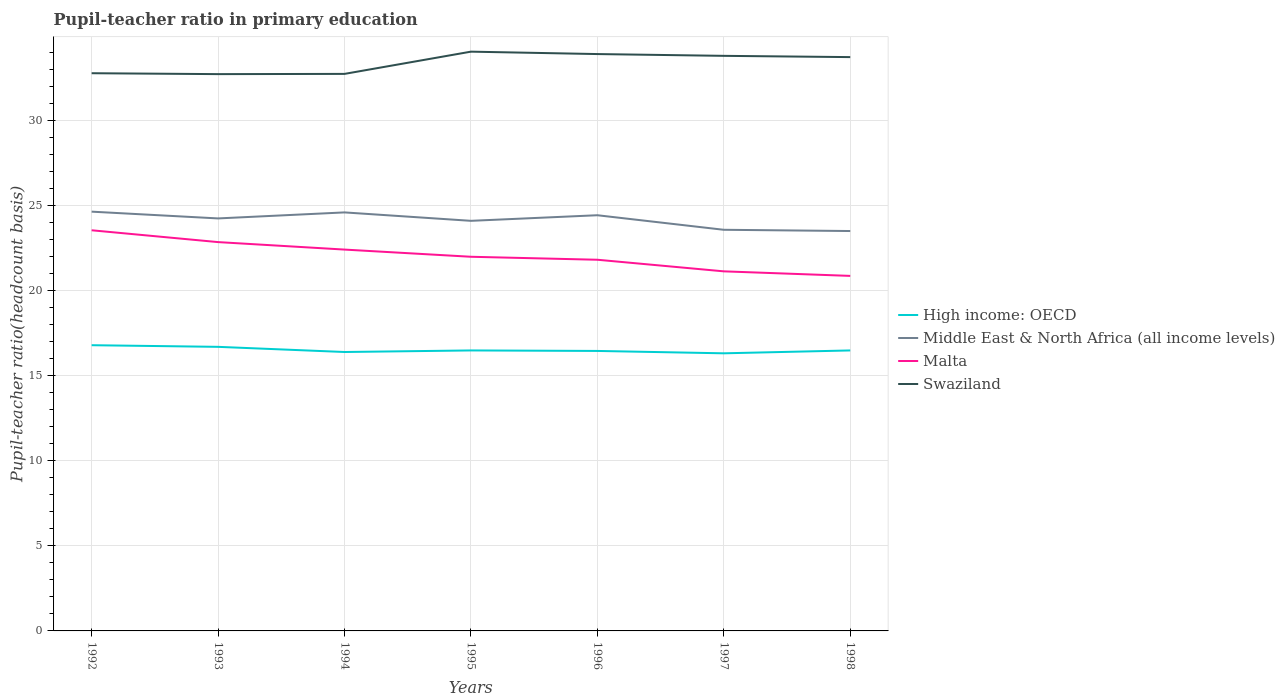How many different coloured lines are there?
Ensure brevity in your answer.  4. Is the number of lines equal to the number of legend labels?
Provide a short and direct response. Yes. Across all years, what is the maximum pupil-teacher ratio in primary education in High income: OECD?
Make the answer very short. 16.3. What is the total pupil-teacher ratio in primary education in Middle East & North Africa (all income levels) in the graph?
Give a very brief answer. 0.07. What is the difference between the highest and the second highest pupil-teacher ratio in primary education in Swaziland?
Offer a very short reply. 1.32. How many lines are there?
Your answer should be compact. 4. How many years are there in the graph?
Provide a short and direct response. 7. Are the values on the major ticks of Y-axis written in scientific E-notation?
Make the answer very short. No. Does the graph contain any zero values?
Offer a terse response. No. Does the graph contain grids?
Ensure brevity in your answer.  Yes. How many legend labels are there?
Give a very brief answer. 4. What is the title of the graph?
Your response must be concise. Pupil-teacher ratio in primary education. What is the label or title of the Y-axis?
Provide a succinct answer. Pupil-teacher ratio(headcount basis). What is the Pupil-teacher ratio(headcount basis) in High income: OECD in 1992?
Keep it short and to the point. 16.78. What is the Pupil-teacher ratio(headcount basis) in Middle East & North Africa (all income levels) in 1992?
Offer a terse response. 24.62. What is the Pupil-teacher ratio(headcount basis) in Malta in 1992?
Provide a short and direct response. 23.53. What is the Pupil-teacher ratio(headcount basis) of Swaziland in 1992?
Your answer should be very brief. 32.76. What is the Pupil-teacher ratio(headcount basis) in High income: OECD in 1993?
Provide a succinct answer. 16.68. What is the Pupil-teacher ratio(headcount basis) in Middle East & North Africa (all income levels) in 1993?
Your answer should be very brief. 24.23. What is the Pupil-teacher ratio(headcount basis) in Malta in 1993?
Offer a terse response. 22.84. What is the Pupil-teacher ratio(headcount basis) of Swaziland in 1993?
Your answer should be very brief. 32.7. What is the Pupil-teacher ratio(headcount basis) of High income: OECD in 1994?
Make the answer very short. 16.38. What is the Pupil-teacher ratio(headcount basis) of Middle East & North Africa (all income levels) in 1994?
Ensure brevity in your answer.  24.58. What is the Pupil-teacher ratio(headcount basis) in Malta in 1994?
Keep it short and to the point. 22.4. What is the Pupil-teacher ratio(headcount basis) of Swaziland in 1994?
Ensure brevity in your answer.  32.72. What is the Pupil-teacher ratio(headcount basis) in High income: OECD in 1995?
Your response must be concise. 16.47. What is the Pupil-teacher ratio(headcount basis) in Middle East & North Africa (all income levels) in 1995?
Ensure brevity in your answer.  24.09. What is the Pupil-teacher ratio(headcount basis) of Malta in 1995?
Make the answer very short. 21.98. What is the Pupil-teacher ratio(headcount basis) in Swaziland in 1995?
Offer a very short reply. 34.02. What is the Pupil-teacher ratio(headcount basis) of High income: OECD in 1996?
Provide a short and direct response. 16.44. What is the Pupil-teacher ratio(headcount basis) in Middle East & North Africa (all income levels) in 1996?
Give a very brief answer. 24.41. What is the Pupil-teacher ratio(headcount basis) of Malta in 1996?
Make the answer very short. 21.8. What is the Pupil-teacher ratio(headcount basis) of Swaziland in 1996?
Provide a short and direct response. 33.88. What is the Pupil-teacher ratio(headcount basis) of High income: OECD in 1997?
Ensure brevity in your answer.  16.3. What is the Pupil-teacher ratio(headcount basis) in Middle East & North Africa (all income levels) in 1997?
Provide a short and direct response. 23.56. What is the Pupil-teacher ratio(headcount basis) in Malta in 1997?
Give a very brief answer. 21.12. What is the Pupil-teacher ratio(headcount basis) of Swaziland in 1997?
Make the answer very short. 33.78. What is the Pupil-teacher ratio(headcount basis) in High income: OECD in 1998?
Offer a very short reply. 16.47. What is the Pupil-teacher ratio(headcount basis) of Middle East & North Africa (all income levels) in 1998?
Provide a succinct answer. 23.49. What is the Pupil-teacher ratio(headcount basis) of Malta in 1998?
Your answer should be very brief. 20.85. What is the Pupil-teacher ratio(headcount basis) of Swaziland in 1998?
Give a very brief answer. 33.7. Across all years, what is the maximum Pupil-teacher ratio(headcount basis) of High income: OECD?
Keep it short and to the point. 16.78. Across all years, what is the maximum Pupil-teacher ratio(headcount basis) in Middle East & North Africa (all income levels)?
Provide a short and direct response. 24.62. Across all years, what is the maximum Pupil-teacher ratio(headcount basis) in Malta?
Give a very brief answer. 23.53. Across all years, what is the maximum Pupil-teacher ratio(headcount basis) in Swaziland?
Provide a short and direct response. 34.02. Across all years, what is the minimum Pupil-teacher ratio(headcount basis) of High income: OECD?
Offer a very short reply. 16.3. Across all years, what is the minimum Pupil-teacher ratio(headcount basis) in Middle East & North Africa (all income levels)?
Offer a terse response. 23.49. Across all years, what is the minimum Pupil-teacher ratio(headcount basis) in Malta?
Provide a short and direct response. 20.85. Across all years, what is the minimum Pupil-teacher ratio(headcount basis) in Swaziland?
Your response must be concise. 32.7. What is the total Pupil-teacher ratio(headcount basis) of High income: OECD in the graph?
Offer a very short reply. 115.54. What is the total Pupil-teacher ratio(headcount basis) of Middle East & North Africa (all income levels) in the graph?
Make the answer very short. 168.98. What is the total Pupil-teacher ratio(headcount basis) in Malta in the graph?
Your response must be concise. 154.51. What is the total Pupil-teacher ratio(headcount basis) in Swaziland in the graph?
Offer a very short reply. 233.55. What is the difference between the Pupil-teacher ratio(headcount basis) of High income: OECD in 1992 and that in 1993?
Provide a succinct answer. 0.1. What is the difference between the Pupil-teacher ratio(headcount basis) of Middle East & North Africa (all income levels) in 1992 and that in 1993?
Provide a short and direct response. 0.4. What is the difference between the Pupil-teacher ratio(headcount basis) in Malta in 1992 and that in 1993?
Offer a very short reply. 0.69. What is the difference between the Pupil-teacher ratio(headcount basis) in Swaziland in 1992 and that in 1993?
Ensure brevity in your answer.  0.05. What is the difference between the Pupil-teacher ratio(headcount basis) of High income: OECD in 1992 and that in 1994?
Your answer should be very brief. 0.4. What is the difference between the Pupil-teacher ratio(headcount basis) of Middle East & North Africa (all income levels) in 1992 and that in 1994?
Make the answer very short. 0.04. What is the difference between the Pupil-teacher ratio(headcount basis) in Malta in 1992 and that in 1994?
Your response must be concise. 1.13. What is the difference between the Pupil-teacher ratio(headcount basis) of Swaziland in 1992 and that in 1994?
Make the answer very short. 0.04. What is the difference between the Pupil-teacher ratio(headcount basis) of High income: OECD in 1992 and that in 1995?
Keep it short and to the point. 0.31. What is the difference between the Pupil-teacher ratio(headcount basis) in Middle East & North Africa (all income levels) in 1992 and that in 1995?
Offer a terse response. 0.54. What is the difference between the Pupil-teacher ratio(headcount basis) in Malta in 1992 and that in 1995?
Your response must be concise. 1.56. What is the difference between the Pupil-teacher ratio(headcount basis) of Swaziland in 1992 and that in 1995?
Your response must be concise. -1.27. What is the difference between the Pupil-teacher ratio(headcount basis) in High income: OECD in 1992 and that in 1996?
Your response must be concise. 0.34. What is the difference between the Pupil-teacher ratio(headcount basis) of Middle East & North Africa (all income levels) in 1992 and that in 1996?
Your answer should be very brief. 0.21. What is the difference between the Pupil-teacher ratio(headcount basis) in Malta in 1992 and that in 1996?
Your answer should be very brief. 1.73. What is the difference between the Pupil-teacher ratio(headcount basis) in Swaziland in 1992 and that in 1996?
Your answer should be compact. -1.13. What is the difference between the Pupil-teacher ratio(headcount basis) in High income: OECD in 1992 and that in 1997?
Your response must be concise. 0.48. What is the difference between the Pupil-teacher ratio(headcount basis) in Middle East & North Africa (all income levels) in 1992 and that in 1997?
Keep it short and to the point. 1.06. What is the difference between the Pupil-teacher ratio(headcount basis) of Malta in 1992 and that in 1997?
Offer a very short reply. 2.41. What is the difference between the Pupil-teacher ratio(headcount basis) of Swaziland in 1992 and that in 1997?
Your response must be concise. -1.02. What is the difference between the Pupil-teacher ratio(headcount basis) of High income: OECD in 1992 and that in 1998?
Your answer should be compact. 0.31. What is the difference between the Pupil-teacher ratio(headcount basis) in Middle East & North Africa (all income levels) in 1992 and that in 1998?
Keep it short and to the point. 1.14. What is the difference between the Pupil-teacher ratio(headcount basis) in Malta in 1992 and that in 1998?
Keep it short and to the point. 2.68. What is the difference between the Pupil-teacher ratio(headcount basis) in Swaziland in 1992 and that in 1998?
Offer a terse response. -0.95. What is the difference between the Pupil-teacher ratio(headcount basis) of High income: OECD in 1993 and that in 1994?
Your response must be concise. 0.3. What is the difference between the Pupil-teacher ratio(headcount basis) of Middle East & North Africa (all income levels) in 1993 and that in 1994?
Your response must be concise. -0.35. What is the difference between the Pupil-teacher ratio(headcount basis) of Malta in 1993 and that in 1994?
Ensure brevity in your answer.  0.44. What is the difference between the Pupil-teacher ratio(headcount basis) in Swaziland in 1993 and that in 1994?
Give a very brief answer. -0.01. What is the difference between the Pupil-teacher ratio(headcount basis) of High income: OECD in 1993 and that in 1995?
Your answer should be compact. 0.21. What is the difference between the Pupil-teacher ratio(headcount basis) in Middle East & North Africa (all income levels) in 1993 and that in 1995?
Your response must be concise. 0.14. What is the difference between the Pupil-teacher ratio(headcount basis) of Malta in 1993 and that in 1995?
Give a very brief answer. 0.86. What is the difference between the Pupil-teacher ratio(headcount basis) of Swaziland in 1993 and that in 1995?
Provide a short and direct response. -1.32. What is the difference between the Pupil-teacher ratio(headcount basis) of High income: OECD in 1993 and that in 1996?
Your answer should be very brief. 0.24. What is the difference between the Pupil-teacher ratio(headcount basis) of Middle East & North Africa (all income levels) in 1993 and that in 1996?
Provide a succinct answer. -0.19. What is the difference between the Pupil-teacher ratio(headcount basis) in Malta in 1993 and that in 1996?
Provide a succinct answer. 1.04. What is the difference between the Pupil-teacher ratio(headcount basis) in Swaziland in 1993 and that in 1996?
Your answer should be compact. -1.18. What is the difference between the Pupil-teacher ratio(headcount basis) in High income: OECD in 1993 and that in 1997?
Your answer should be compact. 0.38. What is the difference between the Pupil-teacher ratio(headcount basis) of Middle East & North Africa (all income levels) in 1993 and that in 1997?
Ensure brevity in your answer.  0.67. What is the difference between the Pupil-teacher ratio(headcount basis) of Malta in 1993 and that in 1997?
Keep it short and to the point. 1.72. What is the difference between the Pupil-teacher ratio(headcount basis) of Swaziland in 1993 and that in 1997?
Ensure brevity in your answer.  -1.07. What is the difference between the Pupil-teacher ratio(headcount basis) of High income: OECD in 1993 and that in 1998?
Keep it short and to the point. 0.21. What is the difference between the Pupil-teacher ratio(headcount basis) in Middle East & North Africa (all income levels) in 1993 and that in 1998?
Your answer should be very brief. 0.74. What is the difference between the Pupil-teacher ratio(headcount basis) of Malta in 1993 and that in 1998?
Your response must be concise. 1.98. What is the difference between the Pupil-teacher ratio(headcount basis) in Swaziland in 1993 and that in 1998?
Provide a short and direct response. -1. What is the difference between the Pupil-teacher ratio(headcount basis) in High income: OECD in 1994 and that in 1995?
Provide a short and direct response. -0.09. What is the difference between the Pupil-teacher ratio(headcount basis) of Middle East & North Africa (all income levels) in 1994 and that in 1995?
Your answer should be very brief. 0.49. What is the difference between the Pupil-teacher ratio(headcount basis) of Malta in 1994 and that in 1995?
Make the answer very short. 0.42. What is the difference between the Pupil-teacher ratio(headcount basis) in Swaziland in 1994 and that in 1995?
Offer a terse response. -1.31. What is the difference between the Pupil-teacher ratio(headcount basis) in High income: OECD in 1994 and that in 1996?
Provide a succinct answer. -0.06. What is the difference between the Pupil-teacher ratio(headcount basis) of Middle East & North Africa (all income levels) in 1994 and that in 1996?
Provide a short and direct response. 0.17. What is the difference between the Pupil-teacher ratio(headcount basis) of Malta in 1994 and that in 1996?
Your answer should be very brief. 0.6. What is the difference between the Pupil-teacher ratio(headcount basis) in Swaziland in 1994 and that in 1996?
Offer a very short reply. -1.17. What is the difference between the Pupil-teacher ratio(headcount basis) of High income: OECD in 1994 and that in 1997?
Offer a terse response. 0.08. What is the difference between the Pupil-teacher ratio(headcount basis) in Middle East & North Africa (all income levels) in 1994 and that in 1997?
Your response must be concise. 1.02. What is the difference between the Pupil-teacher ratio(headcount basis) in Malta in 1994 and that in 1997?
Ensure brevity in your answer.  1.28. What is the difference between the Pupil-teacher ratio(headcount basis) of Swaziland in 1994 and that in 1997?
Make the answer very short. -1.06. What is the difference between the Pupil-teacher ratio(headcount basis) of High income: OECD in 1994 and that in 1998?
Your response must be concise. -0.09. What is the difference between the Pupil-teacher ratio(headcount basis) of Middle East & North Africa (all income levels) in 1994 and that in 1998?
Provide a succinct answer. 1.09. What is the difference between the Pupil-teacher ratio(headcount basis) in Malta in 1994 and that in 1998?
Your answer should be very brief. 1.55. What is the difference between the Pupil-teacher ratio(headcount basis) in Swaziland in 1994 and that in 1998?
Make the answer very short. -0.99. What is the difference between the Pupil-teacher ratio(headcount basis) in High income: OECD in 1995 and that in 1996?
Provide a short and direct response. 0.03. What is the difference between the Pupil-teacher ratio(headcount basis) in Middle East & North Africa (all income levels) in 1995 and that in 1996?
Your answer should be compact. -0.33. What is the difference between the Pupil-teacher ratio(headcount basis) in Malta in 1995 and that in 1996?
Give a very brief answer. 0.18. What is the difference between the Pupil-teacher ratio(headcount basis) of Swaziland in 1995 and that in 1996?
Provide a short and direct response. 0.14. What is the difference between the Pupil-teacher ratio(headcount basis) of High income: OECD in 1995 and that in 1997?
Your answer should be very brief. 0.17. What is the difference between the Pupil-teacher ratio(headcount basis) of Middle East & North Africa (all income levels) in 1995 and that in 1997?
Offer a very short reply. 0.53. What is the difference between the Pupil-teacher ratio(headcount basis) of Malta in 1995 and that in 1997?
Offer a very short reply. 0.86. What is the difference between the Pupil-teacher ratio(headcount basis) in Swaziland in 1995 and that in 1997?
Give a very brief answer. 0.25. What is the difference between the Pupil-teacher ratio(headcount basis) in Middle East & North Africa (all income levels) in 1995 and that in 1998?
Provide a succinct answer. 0.6. What is the difference between the Pupil-teacher ratio(headcount basis) of Malta in 1995 and that in 1998?
Offer a very short reply. 1.12. What is the difference between the Pupil-teacher ratio(headcount basis) of Swaziland in 1995 and that in 1998?
Make the answer very short. 0.32. What is the difference between the Pupil-teacher ratio(headcount basis) of High income: OECD in 1996 and that in 1997?
Offer a very short reply. 0.14. What is the difference between the Pupil-teacher ratio(headcount basis) of Middle East & North Africa (all income levels) in 1996 and that in 1997?
Your answer should be very brief. 0.85. What is the difference between the Pupil-teacher ratio(headcount basis) in Malta in 1996 and that in 1997?
Offer a terse response. 0.68. What is the difference between the Pupil-teacher ratio(headcount basis) in Swaziland in 1996 and that in 1997?
Your answer should be compact. 0.11. What is the difference between the Pupil-teacher ratio(headcount basis) in High income: OECD in 1996 and that in 1998?
Your response must be concise. -0.03. What is the difference between the Pupil-teacher ratio(headcount basis) of Middle East & North Africa (all income levels) in 1996 and that in 1998?
Offer a very short reply. 0.93. What is the difference between the Pupil-teacher ratio(headcount basis) of Malta in 1996 and that in 1998?
Keep it short and to the point. 0.95. What is the difference between the Pupil-teacher ratio(headcount basis) in Swaziland in 1996 and that in 1998?
Your answer should be compact. 0.18. What is the difference between the Pupil-teacher ratio(headcount basis) of High income: OECD in 1997 and that in 1998?
Your response must be concise. -0.17. What is the difference between the Pupil-teacher ratio(headcount basis) in Middle East & North Africa (all income levels) in 1997 and that in 1998?
Provide a succinct answer. 0.07. What is the difference between the Pupil-teacher ratio(headcount basis) in Malta in 1997 and that in 1998?
Your answer should be compact. 0.27. What is the difference between the Pupil-teacher ratio(headcount basis) of Swaziland in 1997 and that in 1998?
Provide a short and direct response. 0.07. What is the difference between the Pupil-teacher ratio(headcount basis) of High income: OECD in 1992 and the Pupil-teacher ratio(headcount basis) of Middle East & North Africa (all income levels) in 1993?
Your answer should be very brief. -7.45. What is the difference between the Pupil-teacher ratio(headcount basis) of High income: OECD in 1992 and the Pupil-teacher ratio(headcount basis) of Malta in 1993?
Your answer should be very brief. -6.06. What is the difference between the Pupil-teacher ratio(headcount basis) in High income: OECD in 1992 and the Pupil-teacher ratio(headcount basis) in Swaziland in 1993?
Keep it short and to the point. -15.92. What is the difference between the Pupil-teacher ratio(headcount basis) in Middle East & North Africa (all income levels) in 1992 and the Pupil-teacher ratio(headcount basis) in Malta in 1993?
Ensure brevity in your answer.  1.79. What is the difference between the Pupil-teacher ratio(headcount basis) of Middle East & North Africa (all income levels) in 1992 and the Pupil-teacher ratio(headcount basis) of Swaziland in 1993?
Ensure brevity in your answer.  -8.08. What is the difference between the Pupil-teacher ratio(headcount basis) in Malta in 1992 and the Pupil-teacher ratio(headcount basis) in Swaziland in 1993?
Your answer should be very brief. -9.17. What is the difference between the Pupil-teacher ratio(headcount basis) in High income: OECD in 1992 and the Pupil-teacher ratio(headcount basis) in Middle East & North Africa (all income levels) in 1994?
Offer a terse response. -7.8. What is the difference between the Pupil-teacher ratio(headcount basis) in High income: OECD in 1992 and the Pupil-teacher ratio(headcount basis) in Malta in 1994?
Give a very brief answer. -5.62. What is the difference between the Pupil-teacher ratio(headcount basis) in High income: OECD in 1992 and the Pupil-teacher ratio(headcount basis) in Swaziland in 1994?
Provide a short and direct response. -15.93. What is the difference between the Pupil-teacher ratio(headcount basis) of Middle East & North Africa (all income levels) in 1992 and the Pupil-teacher ratio(headcount basis) of Malta in 1994?
Give a very brief answer. 2.23. What is the difference between the Pupil-teacher ratio(headcount basis) of Middle East & North Africa (all income levels) in 1992 and the Pupil-teacher ratio(headcount basis) of Swaziland in 1994?
Make the answer very short. -8.09. What is the difference between the Pupil-teacher ratio(headcount basis) in Malta in 1992 and the Pupil-teacher ratio(headcount basis) in Swaziland in 1994?
Your response must be concise. -9.18. What is the difference between the Pupil-teacher ratio(headcount basis) in High income: OECD in 1992 and the Pupil-teacher ratio(headcount basis) in Middle East & North Africa (all income levels) in 1995?
Your answer should be very brief. -7.3. What is the difference between the Pupil-teacher ratio(headcount basis) of High income: OECD in 1992 and the Pupil-teacher ratio(headcount basis) of Malta in 1995?
Offer a very short reply. -5.19. What is the difference between the Pupil-teacher ratio(headcount basis) in High income: OECD in 1992 and the Pupil-teacher ratio(headcount basis) in Swaziland in 1995?
Offer a terse response. -17.24. What is the difference between the Pupil-teacher ratio(headcount basis) in Middle East & North Africa (all income levels) in 1992 and the Pupil-teacher ratio(headcount basis) in Malta in 1995?
Offer a terse response. 2.65. What is the difference between the Pupil-teacher ratio(headcount basis) in Middle East & North Africa (all income levels) in 1992 and the Pupil-teacher ratio(headcount basis) in Swaziland in 1995?
Provide a succinct answer. -9.4. What is the difference between the Pupil-teacher ratio(headcount basis) of Malta in 1992 and the Pupil-teacher ratio(headcount basis) of Swaziland in 1995?
Your response must be concise. -10.49. What is the difference between the Pupil-teacher ratio(headcount basis) in High income: OECD in 1992 and the Pupil-teacher ratio(headcount basis) in Middle East & North Africa (all income levels) in 1996?
Ensure brevity in your answer.  -7.63. What is the difference between the Pupil-teacher ratio(headcount basis) in High income: OECD in 1992 and the Pupil-teacher ratio(headcount basis) in Malta in 1996?
Your answer should be very brief. -5.02. What is the difference between the Pupil-teacher ratio(headcount basis) of High income: OECD in 1992 and the Pupil-teacher ratio(headcount basis) of Swaziland in 1996?
Offer a terse response. -17.1. What is the difference between the Pupil-teacher ratio(headcount basis) of Middle East & North Africa (all income levels) in 1992 and the Pupil-teacher ratio(headcount basis) of Malta in 1996?
Your response must be concise. 2.82. What is the difference between the Pupil-teacher ratio(headcount basis) of Middle East & North Africa (all income levels) in 1992 and the Pupil-teacher ratio(headcount basis) of Swaziland in 1996?
Your answer should be compact. -9.26. What is the difference between the Pupil-teacher ratio(headcount basis) of Malta in 1992 and the Pupil-teacher ratio(headcount basis) of Swaziland in 1996?
Offer a terse response. -10.35. What is the difference between the Pupil-teacher ratio(headcount basis) of High income: OECD in 1992 and the Pupil-teacher ratio(headcount basis) of Middle East & North Africa (all income levels) in 1997?
Your answer should be compact. -6.78. What is the difference between the Pupil-teacher ratio(headcount basis) of High income: OECD in 1992 and the Pupil-teacher ratio(headcount basis) of Malta in 1997?
Ensure brevity in your answer.  -4.34. What is the difference between the Pupil-teacher ratio(headcount basis) of High income: OECD in 1992 and the Pupil-teacher ratio(headcount basis) of Swaziland in 1997?
Keep it short and to the point. -16.99. What is the difference between the Pupil-teacher ratio(headcount basis) of Middle East & North Africa (all income levels) in 1992 and the Pupil-teacher ratio(headcount basis) of Malta in 1997?
Make the answer very short. 3.51. What is the difference between the Pupil-teacher ratio(headcount basis) in Middle East & North Africa (all income levels) in 1992 and the Pupil-teacher ratio(headcount basis) in Swaziland in 1997?
Keep it short and to the point. -9.15. What is the difference between the Pupil-teacher ratio(headcount basis) of Malta in 1992 and the Pupil-teacher ratio(headcount basis) of Swaziland in 1997?
Give a very brief answer. -10.24. What is the difference between the Pupil-teacher ratio(headcount basis) in High income: OECD in 1992 and the Pupil-teacher ratio(headcount basis) in Middle East & North Africa (all income levels) in 1998?
Offer a terse response. -6.71. What is the difference between the Pupil-teacher ratio(headcount basis) of High income: OECD in 1992 and the Pupil-teacher ratio(headcount basis) of Malta in 1998?
Your response must be concise. -4.07. What is the difference between the Pupil-teacher ratio(headcount basis) in High income: OECD in 1992 and the Pupil-teacher ratio(headcount basis) in Swaziland in 1998?
Offer a terse response. -16.92. What is the difference between the Pupil-teacher ratio(headcount basis) of Middle East & North Africa (all income levels) in 1992 and the Pupil-teacher ratio(headcount basis) of Malta in 1998?
Your answer should be compact. 3.77. What is the difference between the Pupil-teacher ratio(headcount basis) of Middle East & North Africa (all income levels) in 1992 and the Pupil-teacher ratio(headcount basis) of Swaziland in 1998?
Your answer should be compact. -9.08. What is the difference between the Pupil-teacher ratio(headcount basis) in Malta in 1992 and the Pupil-teacher ratio(headcount basis) in Swaziland in 1998?
Keep it short and to the point. -10.17. What is the difference between the Pupil-teacher ratio(headcount basis) in High income: OECD in 1993 and the Pupil-teacher ratio(headcount basis) in Middle East & North Africa (all income levels) in 1994?
Offer a terse response. -7.9. What is the difference between the Pupil-teacher ratio(headcount basis) of High income: OECD in 1993 and the Pupil-teacher ratio(headcount basis) of Malta in 1994?
Provide a short and direct response. -5.71. What is the difference between the Pupil-teacher ratio(headcount basis) of High income: OECD in 1993 and the Pupil-teacher ratio(headcount basis) of Swaziland in 1994?
Your answer should be compact. -16.03. What is the difference between the Pupil-teacher ratio(headcount basis) of Middle East & North Africa (all income levels) in 1993 and the Pupil-teacher ratio(headcount basis) of Malta in 1994?
Provide a short and direct response. 1.83. What is the difference between the Pupil-teacher ratio(headcount basis) in Middle East & North Africa (all income levels) in 1993 and the Pupil-teacher ratio(headcount basis) in Swaziland in 1994?
Provide a short and direct response. -8.49. What is the difference between the Pupil-teacher ratio(headcount basis) in Malta in 1993 and the Pupil-teacher ratio(headcount basis) in Swaziland in 1994?
Your response must be concise. -9.88. What is the difference between the Pupil-teacher ratio(headcount basis) in High income: OECD in 1993 and the Pupil-teacher ratio(headcount basis) in Middle East & North Africa (all income levels) in 1995?
Ensure brevity in your answer.  -7.4. What is the difference between the Pupil-teacher ratio(headcount basis) of High income: OECD in 1993 and the Pupil-teacher ratio(headcount basis) of Malta in 1995?
Make the answer very short. -5.29. What is the difference between the Pupil-teacher ratio(headcount basis) in High income: OECD in 1993 and the Pupil-teacher ratio(headcount basis) in Swaziland in 1995?
Provide a succinct answer. -17.34. What is the difference between the Pupil-teacher ratio(headcount basis) of Middle East & North Africa (all income levels) in 1993 and the Pupil-teacher ratio(headcount basis) of Malta in 1995?
Give a very brief answer. 2.25. What is the difference between the Pupil-teacher ratio(headcount basis) of Middle East & North Africa (all income levels) in 1993 and the Pupil-teacher ratio(headcount basis) of Swaziland in 1995?
Your answer should be very brief. -9.79. What is the difference between the Pupil-teacher ratio(headcount basis) in Malta in 1993 and the Pupil-teacher ratio(headcount basis) in Swaziland in 1995?
Offer a terse response. -11.19. What is the difference between the Pupil-teacher ratio(headcount basis) in High income: OECD in 1993 and the Pupil-teacher ratio(headcount basis) in Middle East & North Africa (all income levels) in 1996?
Your response must be concise. -7.73. What is the difference between the Pupil-teacher ratio(headcount basis) in High income: OECD in 1993 and the Pupil-teacher ratio(headcount basis) in Malta in 1996?
Provide a short and direct response. -5.12. What is the difference between the Pupil-teacher ratio(headcount basis) in High income: OECD in 1993 and the Pupil-teacher ratio(headcount basis) in Swaziland in 1996?
Keep it short and to the point. -17.2. What is the difference between the Pupil-teacher ratio(headcount basis) in Middle East & North Africa (all income levels) in 1993 and the Pupil-teacher ratio(headcount basis) in Malta in 1996?
Provide a short and direct response. 2.43. What is the difference between the Pupil-teacher ratio(headcount basis) of Middle East & North Africa (all income levels) in 1993 and the Pupil-teacher ratio(headcount basis) of Swaziland in 1996?
Provide a short and direct response. -9.65. What is the difference between the Pupil-teacher ratio(headcount basis) of Malta in 1993 and the Pupil-teacher ratio(headcount basis) of Swaziland in 1996?
Your response must be concise. -11.04. What is the difference between the Pupil-teacher ratio(headcount basis) in High income: OECD in 1993 and the Pupil-teacher ratio(headcount basis) in Middle East & North Africa (all income levels) in 1997?
Your answer should be very brief. -6.88. What is the difference between the Pupil-teacher ratio(headcount basis) in High income: OECD in 1993 and the Pupil-teacher ratio(headcount basis) in Malta in 1997?
Ensure brevity in your answer.  -4.43. What is the difference between the Pupil-teacher ratio(headcount basis) of High income: OECD in 1993 and the Pupil-teacher ratio(headcount basis) of Swaziland in 1997?
Your answer should be compact. -17.09. What is the difference between the Pupil-teacher ratio(headcount basis) in Middle East & North Africa (all income levels) in 1993 and the Pupil-teacher ratio(headcount basis) in Malta in 1997?
Make the answer very short. 3.11. What is the difference between the Pupil-teacher ratio(headcount basis) in Middle East & North Africa (all income levels) in 1993 and the Pupil-teacher ratio(headcount basis) in Swaziland in 1997?
Offer a terse response. -9.55. What is the difference between the Pupil-teacher ratio(headcount basis) in Malta in 1993 and the Pupil-teacher ratio(headcount basis) in Swaziland in 1997?
Your answer should be very brief. -10.94. What is the difference between the Pupil-teacher ratio(headcount basis) of High income: OECD in 1993 and the Pupil-teacher ratio(headcount basis) of Middle East & North Africa (all income levels) in 1998?
Your response must be concise. -6.8. What is the difference between the Pupil-teacher ratio(headcount basis) in High income: OECD in 1993 and the Pupil-teacher ratio(headcount basis) in Malta in 1998?
Offer a terse response. -4.17. What is the difference between the Pupil-teacher ratio(headcount basis) of High income: OECD in 1993 and the Pupil-teacher ratio(headcount basis) of Swaziland in 1998?
Make the answer very short. -17.02. What is the difference between the Pupil-teacher ratio(headcount basis) of Middle East & North Africa (all income levels) in 1993 and the Pupil-teacher ratio(headcount basis) of Malta in 1998?
Provide a succinct answer. 3.37. What is the difference between the Pupil-teacher ratio(headcount basis) of Middle East & North Africa (all income levels) in 1993 and the Pupil-teacher ratio(headcount basis) of Swaziland in 1998?
Offer a terse response. -9.47. What is the difference between the Pupil-teacher ratio(headcount basis) in Malta in 1993 and the Pupil-teacher ratio(headcount basis) in Swaziland in 1998?
Your answer should be very brief. -10.86. What is the difference between the Pupil-teacher ratio(headcount basis) in High income: OECD in 1994 and the Pupil-teacher ratio(headcount basis) in Middle East & North Africa (all income levels) in 1995?
Provide a succinct answer. -7.7. What is the difference between the Pupil-teacher ratio(headcount basis) in High income: OECD in 1994 and the Pupil-teacher ratio(headcount basis) in Malta in 1995?
Provide a succinct answer. -5.59. What is the difference between the Pupil-teacher ratio(headcount basis) of High income: OECD in 1994 and the Pupil-teacher ratio(headcount basis) of Swaziland in 1995?
Your answer should be very brief. -17.64. What is the difference between the Pupil-teacher ratio(headcount basis) of Middle East & North Africa (all income levels) in 1994 and the Pupil-teacher ratio(headcount basis) of Malta in 1995?
Keep it short and to the point. 2.61. What is the difference between the Pupil-teacher ratio(headcount basis) in Middle East & North Africa (all income levels) in 1994 and the Pupil-teacher ratio(headcount basis) in Swaziland in 1995?
Keep it short and to the point. -9.44. What is the difference between the Pupil-teacher ratio(headcount basis) of Malta in 1994 and the Pupil-teacher ratio(headcount basis) of Swaziland in 1995?
Your answer should be compact. -11.62. What is the difference between the Pupil-teacher ratio(headcount basis) in High income: OECD in 1994 and the Pupil-teacher ratio(headcount basis) in Middle East & North Africa (all income levels) in 1996?
Your answer should be compact. -8.03. What is the difference between the Pupil-teacher ratio(headcount basis) in High income: OECD in 1994 and the Pupil-teacher ratio(headcount basis) in Malta in 1996?
Your answer should be compact. -5.42. What is the difference between the Pupil-teacher ratio(headcount basis) of High income: OECD in 1994 and the Pupil-teacher ratio(headcount basis) of Swaziland in 1996?
Provide a short and direct response. -17.5. What is the difference between the Pupil-teacher ratio(headcount basis) of Middle East & North Africa (all income levels) in 1994 and the Pupil-teacher ratio(headcount basis) of Malta in 1996?
Keep it short and to the point. 2.78. What is the difference between the Pupil-teacher ratio(headcount basis) in Middle East & North Africa (all income levels) in 1994 and the Pupil-teacher ratio(headcount basis) in Swaziland in 1996?
Provide a succinct answer. -9.3. What is the difference between the Pupil-teacher ratio(headcount basis) of Malta in 1994 and the Pupil-teacher ratio(headcount basis) of Swaziland in 1996?
Make the answer very short. -11.48. What is the difference between the Pupil-teacher ratio(headcount basis) of High income: OECD in 1994 and the Pupil-teacher ratio(headcount basis) of Middle East & North Africa (all income levels) in 1997?
Give a very brief answer. -7.18. What is the difference between the Pupil-teacher ratio(headcount basis) of High income: OECD in 1994 and the Pupil-teacher ratio(headcount basis) of Malta in 1997?
Your answer should be compact. -4.74. What is the difference between the Pupil-teacher ratio(headcount basis) in High income: OECD in 1994 and the Pupil-teacher ratio(headcount basis) in Swaziland in 1997?
Give a very brief answer. -17.39. What is the difference between the Pupil-teacher ratio(headcount basis) in Middle East & North Africa (all income levels) in 1994 and the Pupil-teacher ratio(headcount basis) in Malta in 1997?
Ensure brevity in your answer.  3.46. What is the difference between the Pupil-teacher ratio(headcount basis) of Middle East & North Africa (all income levels) in 1994 and the Pupil-teacher ratio(headcount basis) of Swaziland in 1997?
Your answer should be very brief. -9.19. What is the difference between the Pupil-teacher ratio(headcount basis) of Malta in 1994 and the Pupil-teacher ratio(headcount basis) of Swaziland in 1997?
Your response must be concise. -11.38. What is the difference between the Pupil-teacher ratio(headcount basis) of High income: OECD in 1994 and the Pupil-teacher ratio(headcount basis) of Middle East & North Africa (all income levels) in 1998?
Your response must be concise. -7.1. What is the difference between the Pupil-teacher ratio(headcount basis) of High income: OECD in 1994 and the Pupil-teacher ratio(headcount basis) of Malta in 1998?
Your answer should be compact. -4.47. What is the difference between the Pupil-teacher ratio(headcount basis) in High income: OECD in 1994 and the Pupil-teacher ratio(headcount basis) in Swaziland in 1998?
Ensure brevity in your answer.  -17.32. What is the difference between the Pupil-teacher ratio(headcount basis) of Middle East & North Africa (all income levels) in 1994 and the Pupil-teacher ratio(headcount basis) of Malta in 1998?
Your answer should be very brief. 3.73. What is the difference between the Pupil-teacher ratio(headcount basis) in Middle East & North Africa (all income levels) in 1994 and the Pupil-teacher ratio(headcount basis) in Swaziland in 1998?
Your answer should be very brief. -9.12. What is the difference between the Pupil-teacher ratio(headcount basis) in Malta in 1994 and the Pupil-teacher ratio(headcount basis) in Swaziland in 1998?
Offer a terse response. -11.3. What is the difference between the Pupil-teacher ratio(headcount basis) of High income: OECD in 1995 and the Pupil-teacher ratio(headcount basis) of Middle East & North Africa (all income levels) in 1996?
Your answer should be very brief. -7.94. What is the difference between the Pupil-teacher ratio(headcount basis) of High income: OECD in 1995 and the Pupil-teacher ratio(headcount basis) of Malta in 1996?
Make the answer very short. -5.33. What is the difference between the Pupil-teacher ratio(headcount basis) of High income: OECD in 1995 and the Pupil-teacher ratio(headcount basis) of Swaziland in 1996?
Give a very brief answer. -17.41. What is the difference between the Pupil-teacher ratio(headcount basis) of Middle East & North Africa (all income levels) in 1995 and the Pupil-teacher ratio(headcount basis) of Malta in 1996?
Give a very brief answer. 2.29. What is the difference between the Pupil-teacher ratio(headcount basis) of Middle East & North Africa (all income levels) in 1995 and the Pupil-teacher ratio(headcount basis) of Swaziland in 1996?
Offer a very short reply. -9.79. What is the difference between the Pupil-teacher ratio(headcount basis) in Malta in 1995 and the Pupil-teacher ratio(headcount basis) in Swaziland in 1996?
Your response must be concise. -11.91. What is the difference between the Pupil-teacher ratio(headcount basis) of High income: OECD in 1995 and the Pupil-teacher ratio(headcount basis) of Middle East & North Africa (all income levels) in 1997?
Your answer should be very brief. -7.09. What is the difference between the Pupil-teacher ratio(headcount basis) in High income: OECD in 1995 and the Pupil-teacher ratio(headcount basis) in Malta in 1997?
Ensure brevity in your answer.  -4.64. What is the difference between the Pupil-teacher ratio(headcount basis) of High income: OECD in 1995 and the Pupil-teacher ratio(headcount basis) of Swaziland in 1997?
Provide a succinct answer. -17.3. What is the difference between the Pupil-teacher ratio(headcount basis) in Middle East & North Africa (all income levels) in 1995 and the Pupil-teacher ratio(headcount basis) in Malta in 1997?
Provide a short and direct response. 2.97. What is the difference between the Pupil-teacher ratio(headcount basis) of Middle East & North Africa (all income levels) in 1995 and the Pupil-teacher ratio(headcount basis) of Swaziland in 1997?
Your answer should be compact. -9.69. What is the difference between the Pupil-teacher ratio(headcount basis) in Malta in 1995 and the Pupil-teacher ratio(headcount basis) in Swaziland in 1997?
Offer a terse response. -11.8. What is the difference between the Pupil-teacher ratio(headcount basis) of High income: OECD in 1995 and the Pupil-teacher ratio(headcount basis) of Middle East & North Africa (all income levels) in 1998?
Your answer should be compact. -7.01. What is the difference between the Pupil-teacher ratio(headcount basis) of High income: OECD in 1995 and the Pupil-teacher ratio(headcount basis) of Malta in 1998?
Keep it short and to the point. -4.38. What is the difference between the Pupil-teacher ratio(headcount basis) of High income: OECD in 1995 and the Pupil-teacher ratio(headcount basis) of Swaziland in 1998?
Your answer should be compact. -17.23. What is the difference between the Pupil-teacher ratio(headcount basis) of Middle East & North Africa (all income levels) in 1995 and the Pupil-teacher ratio(headcount basis) of Malta in 1998?
Offer a very short reply. 3.23. What is the difference between the Pupil-teacher ratio(headcount basis) in Middle East & North Africa (all income levels) in 1995 and the Pupil-teacher ratio(headcount basis) in Swaziland in 1998?
Offer a terse response. -9.62. What is the difference between the Pupil-teacher ratio(headcount basis) of Malta in 1995 and the Pupil-teacher ratio(headcount basis) of Swaziland in 1998?
Provide a short and direct response. -11.73. What is the difference between the Pupil-teacher ratio(headcount basis) in High income: OECD in 1996 and the Pupil-teacher ratio(headcount basis) in Middle East & North Africa (all income levels) in 1997?
Offer a very short reply. -7.12. What is the difference between the Pupil-teacher ratio(headcount basis) in High income: OECD in 1996 and the Pupil-teacher ratio(headcount basis) in Malta in 1997?
Keep it short and to the point. -4.67. What is the difference between the Pupil-teacher ratio(headcount basis) of High income: OECD in 1996 and the Pupil-teacher ratio(headcount basis) of Swaziland in 1997?
Make the answer very short. -17.33. What is the difference between the Pupil-teacher ratio(headcount basis) in Middle East & North Africa (all income levels) in 1996 and the Pupil-teacher ratio(headcount basis) in Malta in 1997?
Give a very brief answer. 3.3. What is the difference between the Pupil-teacher ratio(headcount basis) of Middle East & North Africa (all income levels) in 1996 and the Pupil-teacher ratio(headcount basis) of Swaziland in 1997?
Provide a succinct answer. -9.36. What is the difference between the Pupil-teacher ratio(headcount basis) of Malta in 1996 and the Pupil-teacher ratio(headcount basis) of Swaziland in 1997?
Your answer should be very brief. -11.98. What is the difference between the Pupil-teacher ratio(headcount basis) in High income: OECD in 1996 and the Pupil-teacher ratio(headcount basis) in Middle East & North Africa (all income levels) in 1998?
Ensure brevity in your answer.  -7.04. What is the difference between the Pupil-teacher ratio(headcount basis) in High income: OECD in 1996 and the Pupil-teacher ratio(headcount basis) in Malta in 1998?
Your answer should be compact. -4.41. What is the difference between the Pupil-teacher ratio(headcount basis) of High income: OECD in 1996 and the Pupil-teacher ratio(headcount basis) of Swaziland in 1998?
Your response must be concise. -17.26. What is the difference between the Pupil-teacher ratio(headcount basis) in Middle East & North Africa (all income levels) in 1996 and the Pupil-teacher ratio(headcount basis) in Malta in 1998?
Your answer should be compact. 3.56. What is the difference between the Pupil-teacher ratio(headcount basis) of Middle East & North Africa (all income levels) in 1996 and the Pupil-teacher ratio(headcount basis) of Swaziland in 1998?
Keep it short and to the point. -9.29. What is the difference between the Pupil-teacher ratio(headcount basis) of Malta in 1996 and the Pupil-teacher ratio(headcount basis) of Swaziland in 1998?
Make the answer very short. -11.9. What is the difference between the Pupil-teacher ratio(headcount basis) in High income: OECD in 1997 and the Pupil-teacher ratio(headcount basis) in Middle East & North Africa (all income levels) in 1998?
Give a very brief answer. -7.18. What is the difference between the Pupil-teacher ratio(headcount basis) in High income: OECD in 1997 and the Pupil-teacher ratio(headcount basis) in Malta in 1998?
Provide a succinct answer. -4.55. What is the difference between the Pupil-teacher ratio(headcount basis) in High income: OECD in 1997 and the Pupil-teacher ratio(headcount basis) in Swaziland in 1998?
Your response must be concise. -17.4. What is the difference between the Pupil-teacher ratio(headcount basis) of Middle East & North Africa (all income levels) in 1997 and the Pupil-teacher ratio(headcount basis) of Malta in 1998?
Give a very brief answer. 2.71. What is the difference between the Pupil-teacher ratio(headcount basis) of Middle East & North Africa (all income levels) in 1997 and the Pupil-teacher ratio(headcount basis) of Swaziland in 1998?
Make the answer very short. -10.14. What is the difference between the Pupil-teacher ratio(headcount basis) in Malta in 1997 and the Pupil-teacher ratio(headcount basis) in Swaziland in 1998?
Offer a terse response. -12.58. What is the average Pupil-teacher ratio(headcount basis) in High income: OECD per year?
Your answer should be compact. 16.51. What is the average Pupil-teacher ratio(headcount basis) of Middle East & North Africa (all income levels) per year?
Provide a succinct answer. 24.14. What is the average Pupil-teacher ratio(headcount basis) of Malta per year?
Keep it short and to the point. 22.07. What is the average Pupil-teacher ratio(headcount basis) in Swaziland per year?
Offer a terse response. 33.36. In the year 1992, what is the difference between the Pupil-teacher ratio(headcount basis) of High income: OECD and Pupil-teacher ratio(headcount basis) of Middle East & North Africa (all income levels)?
Give a very brief answer. -7.84. In the year 1992, what is the difference between the Pupil-teacher ratio(headcount basis) in High income: OECD and Pupil-teacher ratio(headcount basis) in Malta?
Ensure brevity in your answer.  -6.75. In the year 1992, what is the difference between the Pupil-teacher ratio(headcount basis) of High income: OECD and Pupil-teacher ratio(headcount basis) of Swaziland?
Your answer should be very brief. -15.97. In the year 1992, what is the difference between the Pupil-teacher ratio(headcount basis) of Middle East & North Africa (all income levels) and Pupil-teacher ratio(headcount basis) of Malta?
Your answer should be compact. 1.09. In the year 1992, what is the difference between the Pupil-teacher ratio(headcount basis) in Middle East & North Africa (all income levels) and Pupil-teacher ratio(headcount basis) in Swaziland?
Offer a very short reply. -8.13. In the year 1992, what is the difference between the Pupil-teacher ratio(headcount basis) of Malta and Pupil-teacher ratio(headcount basis) of Swaziland?
Provide a short and direct response. -9.22. In the year 1993, what is the difference between the Pupil-teacher ratio(headcount basis) in High income: OECD and Pupil-teacher ratio(headcount basis) in Middle East & North Africa (all income levels)?
Provide a short and direct response. -7.54. In the year 1993, what is the difference between the Pupil-teacher ratio(headcount basis) of High income: OECD and Pupil-teacher ratio(headcount basis) of Malta?
Provide a succinct answer. -6.15. In the year 1993, what is the difference between the Pupil-teacher ratio(headcount basis) of High income: OECD and Pupil-teacher ratio(headcount basis) of Swaziland?
Ensure brevity in your answer.  -16.02. In the year 1993, what is the difference between the Pupil-teacher ratio(headcount basis) in Middle East & North Africa (all income levels) and Pupil-teacher ratio(headcount basis) in Malta?
Provide a short and direct response. 1.39. In the year 1993, what is the difference between the Pupil-teacher ratio(headcount basis) in Middle East & North Africa (all income levels) and Pupil-teacher ratio(headcount basis) in Swaziland?
Give a very brief answer. -8.48. In the year 1993, what is the difference between the Pupil-teacher ratio(headcount basis) of Malta and Pupil-teacher ratio(headcount basis) of Swaziland?
Provide a short and direct response. -9.87. In the year 1994, what is the difference between the Pupil-teacher ratio(headcount basis) in High income: OECD and Pupil-teacher ratio(headcount basis) in Middle East & North Africa (all income levels)?
Your answer should be very brief. -8.2. In the year 1994, what is the difference between the Pupil-teacher ratio(headcount basis) in High income: OECD and Pupil-teacher ratio(headcount basis) in Malta?
Your answer should be compact. -6.02. In the year 1994, what is the difference between the Pupil-teacher ratio(headcount basis) of High income: OECD and Pupil-teacher ratio(headcount basis) of Swaziland?
Keep it short and to the point. -16.33. In the year 1994, what is the difference between the Pupil-teacher ratio(headcount basis) in Middle East & North Africa (all income levels) and Pupil-teacher ratio(headcount basis) in Malta?
Offer a very short reply. 2.18. In the year 1994, what is the difference between the Pupil-teacher ratio(headcount basis) in Middle East & North Africa (all income levels) and Pupil-teacher ratio(headcount basis) in Swaziland?
Make the answer very short. -8.14. In the year 1994, what is the difference between the Pupil-teacher ratio(headcount basis) of Malta and Pupil-teacher ratio(headcount basis) of Swaziland?
Give a very brief answer. -10.32. In the year 1995, what is the difference between the Pupil-teacher ratio(headcount basis) in High income: OECD and Pupil-teacher ratio(headcount basis) in Middle East & North Africa (all income levels)?
Your answer should be very brief. -7.61. In the year 1995, what is the difference between the Pupil-teacher ratio(headcount basis) of High income: OECD and Pupil-teacher ratio(headcount basis) of Malta?
Provide a short and direct response. -5.5. In the year 1995, what is the difference between the Pupil-teacher ratio(headcount basis) in High income: OECD and Pupil-teacher ratio(headcount basis) in Swaziland?
Ensure brevity in your answer.  -17.55. In the year 1995, what is the difference between the Pupil-teacher ratio(headcount basis) in Middle East & North Africa (all income levels) and Pupil-teacher ratio(headcount basis) in Malta?
Your response must be concise. 2.11. In the year 1995, what is the difference between the Pupil-teacher ratio(headcount basis) in Middle East & North Africa (all income levels) and Pupil-teacher ratio(headcount basis) in Swaziland?
Provide a succinct answer. -9.94. In the year 1995, what is the difference between the Pupil-teacher ratio(headcount basis) of Malta and Pupil-teacher ratio(headcount basis) of Swaziland?
Provide a short and direct response. -12.05. In the year 1996, what is the difference between the Pupil-teacher ratio(headcount basis) of High income: OECD and Pupil-teacher ratio(headcount basis) of Middle East & North Africa (all income levels)?
Give a very brief answer. -7.97. In the year 1996, what is the difference between the Pupil-teacher ratio(headcount basis) of High income: OECD and Pupil-teacher ratio(headcount basis) of Malta?
Make the answer very short. -5.36. In the year 1996, what is the difference between the Pupil-teacher ratio(headcount basis) of High income: OECD and Pupil-teacher ratio(headcount basis) of Swaziland?
Provide a short and direct response. -17.44. In the year 1996, what is the difference between the Pupil-teacher ratio(headcount basis) of Middle East & North Africa (all income levels) and Pupil-teacher ratio(headcount basis) of Malta?
Give a very brief answer. 2.61. In the year 1996, what is the difference between the Pupil-teacher ratio(headcount basis) in Middle East & North Africa (all income levels) and Pupil-teacher ratio(headcount basis) in Swaziland?
Ensure brevity in your answer.  -9.47. In the year 1996, what is the difference between the Pupil-teacher ratio(headcount basis) in Malta and Pupil-teacher ratio(headcount basis) in Swaziland?
Offer a terse response. -12.08. In the year 1997, what is the difference between the Pupil-teacher ratio(headcount basis) of High income: OECD and Pupil-teacher ratio(headcount basis) of Middle East & North Africa (all income levels)?
Ensure brevity in your answer.  -7.26. In the year 1997, what is the difference between the Pupil-teacher ratio(headcount basis) of High income: OECD and Pupil-teacher ratio(headcount basis) of Malta?
Keep it short and to the point. -4.81. In the year 1997, what is the difference between the Pupil-teacher ratio(headcount basis) in High income: OECD and Pupil-teacher ratio(headcount basis) in Swaziland?
Give a very brief answer. -17.47. In the year 1997, what is the difference between the Pupil-teacher ratio(headcount basis) in Middle East & North Africa (all income levels) and Pupil-teacher ratio(headcount basis) in Malta?
Keep it short and to the point. 2.44. In the year 1997, what is the difference between the Pupil-teacher ratio(headcount basis) of Middle East & North Africa (all income levels) and Pupil-teacher ratio(headcount basis) of Swaziland?
Give a very brief answer. -10.22. In the year 1997, what is the difference between the Pupil-teacher ratio(headcount basis) of Malta and Pupil-teacher ratio(headcount basis) of Swaziland?
Ensure brevity in your answer.  -12.66. In the year 1998, what is the difference between the Pupil-teacher ratio(headcount basis) of High income: OECD and Pupil-teacher ratio(headcount basis) of Middle East & North Africa (all income levels)?
Give a very brief answer. -7.01. In the year 1998, what is the difference between the Pupil-teacher ratio(headcount basis) of High income: OECD and Pupil-teacher ratio(headcount basis) of Malta?
Ensure brevity in your answer.  -4.38. In the year 1998, what is the difference between the Pupil-teacher ratio(headcount basis) in High income: OECD and Pupil-teacher ratio(headcount basis) in Swaziland?
Provide a succinct answer. -17.23. In the year 1998, what is the difference between the Pupil-teacher ratio(headcount basis) of Middle East & North Africa (all income levels) and Pupil-teacher ratio(headcount basis) of Malta?
Provide a succinct answer. 2.63. In the year 1998, what is the difference between the Pupil-teacher ratio(headcount basis) in Middle East & North Africa (all income levels) and Pupil-teacher ratio(headcount basis) in Swaziland?
Give a very brief answer. -10.21. In the year 1998, what is the difference between the Pupil-teacher ratio(headcount basis) in Malta and Pupil-teacher ratio(headcount basis) in Swaziland?
Give a very brief answer. -12.85. What is the ratio of the Pupil-teacher ratio(headcount basis) in High income: OECD in 1992 to that in 1993?
Your answer should be compact. 1.01. What is the ratio of the Pupil-teacher ratio(headcount basis) of Middle East & North Africa (all income levels) in 1992 to that in 1993?
Your answer should be very brief. 1.02. What is the ratio of the Pupil-teacher ratio(headcount basis) of Malta in 1992 to that in 1993?
Your answer should be very brief. 1.03. What is the ratio of the Pupil-teacher ratio(headcount basis) in High income: OECD in 1992 to that in 1994?
Ensure brevity in your answer.  1.02. What is the ratio of the Pupil-teacher ratio(headcount basis) of Malta in 1992 to that in 1994?
Ensure brevity in your answer.  1.05. What is the ratio of the Pupil-teacher ratio(headcount basis) in Swaziland in 1992 to that in 1994?
Ensure brevity in your answer.  1. What is the ratio of the Pupil-teacher ratio(headcount basis) in High income: OECD in 1992 to that in 1995?
Provide a short and direct response. 1.02. What is the ratio of the Pupil-teacher ratio(headcount basis) of Middle East & North Africa (all income levels) in 1992 to that in 1995?
Your answer should be compact. 1.02. What is the ratio of the Pupil-teacher ratio(headcount basis) in Malta in 1992 to that in 1995?
Your answer should be very brief. 1.07. What is the ratio of the Pupil-teacher ratio(headcount basis) in Swaziland in 1992 to that in 1995?
Offer a very short reply. 0.96. What is the ratio of the Pupil-teacher ratio(headcount basis) of High income: OECD in 1992 to that in 1996?
Provide a succinct answer. 1.02. What is the ratio of the Pupil-teacher ratio(headcount basis) in Middle East & North Africa (all income levels) in 1992 to that in 1996?
Your answer should be compact. 1.01. What is the ratio of the Pupil-teacher ratio(headcount basis) of Malta in 1992 to that in 1996?
Your response must be concise. 1.08. What is the ratio of the Pupil-teacher ratio(headcount basis) in Swaziland in 1992 to that in 1996?
Provide a succinct answer. 0.97. What is the ratio of the Pupil-teacher ratio(headcount basis) in High income: OECD in 1992 to that in 1997?
Your response must be concise. 1.03. What is the ratio of the Pupil-teacher ratio(headcount basis) in Middle East & North Africa (all income levels) in 1992 to that in 1997?
Your answer should be compact. 1.05. What is the ratio of the Pupil-teacher ratio(headcount basis) of Malta in 1992 to that in 1997?
Your response must be concise. 1.11. What is the ratio of the Pupil-teacher ratio(headcount basis) of Swaziland in 1992 to that in 1997?
Keep it short and to the point. 0.97. What is the ratio of the Pupil-teacher ratio(headcount basis) of High income: OECD in 1992 to that in 1998?
Offer a terse response. 1.02. What is the ratio of the Pupil-teacher ratio(headcount basis) in Middle East & North Africa (all income levels) in 1992 to that in 1998?
Offer a very short reply. 1.05. What is the ratio of the Pupil-teacher ratio(headcount basis) of Malta in 1992 to that in 1998?
Provide a succinct answer. 1.13. What is the ratio of the Pupil-teacher ratio(headcount basis) in Swaziland in 1992 to that in 1998?
Provide a succinct answer. 0.97. What is the ratio of the Pupil-teacher ratio(headcount basis) of High income: OECD in 1993 to that in 1994?
Ensure brevity in your answer.  1.02. What is the ratio of the Pupil-teacher ratio(headcount basis) of Middle East & North Africa (all income levels) in 1993 to that in 1994?
Ensure brevity in your answer.  0.99. What is the ratio of the Pupil-teacher ratio(headcount basis) of Malta in 1993 to that in 1994?
Give a very brief answer. 1.02. What is the ratio of the Pupil-teacher ratio(headcount basis) in High income: OECD in 1993 to that in 1995?
Ensure brevity in your answer.  1.01. What is the ratio of the Pupil-teacher ratio(headcount basis) in Middle East & North Africa (all income levels) in 1993 to that in 1995?
Offer a terse response. 1.01. What is the ratio of the Pupil-teacher ratio(headcount basis) in Malta in 1993 to that in 1995?
Your answer should be very brief. 1.04. What is the ratio of the Pupil-teacher ratio(headcount basis) of Swaziland in 1993 to that in 1995?
Your response must be concise. 0.96. What is the ratio of the Pupil-teacher ratio(headcount basis) of High income: OECD in 1993 to that in 1996?
Make the answer very short. 1.01. What is the ratio of the Pupil-teacher ratio(headcount basis) of Middle East & North Africa (all income levels) in 1993 to that in 1996?
Provide a succinct answer. 0.99. What is the ratio of the Pupil-teacher ratio(headcount basis) of Malta in 1993 to that in 1996?
Offer a very short reply. 1.05. What is the ratio of the Pupil-teacher ratio(headcount basis) in Swaziland in 1993 to that in 1996?
Give a very brief answer. 0.97. What is the ratio of the Pupil-teacher ratio(headcount basis) in High income: OECD in 1993 to that in 1997?
Offer a very short reply. 1.02. What is the ratio of the Pupil-teacher ratio(headcount basis) of Middle East & North Africa (all income levels) in 1993 to that in 1997?
Your answer should be very brief. 1.03. What is the ratio of the Pupil-teacher ratio(headcount basis) in Malta in 1993 to that in 1997?
Offer a terse response. 1.08. What is the ratio of the Pupil-teacher ratio(headcount basis) of Swaziland in 1993 to that in 1997?
Provide a short and direct response. 0.97. What is the ratio of the Pupil-teacher ratio(headcount basis) in High income: OECD in 1993 to that in 1998?
Provide a succinct answer. 1.01. What is the ratio of the Pupil-teacher ratio(headcount basis) in Middle East & North Africa (all income levels) in 1993 to that in 1998?
Make the answer very short. 1.03. What is the ratio of the Pupil-teacher ratio(headcount basis) of Malta in 1993 to that in 1998?
Make the answer very short. 1.1. What is the ratio of the Pupil-teacher ratio(headcount basis) of Swaziland in 1993 to that in 1998?
Provide a succinct answer. 0.97. What is the ratio of the Pupil-teacher ratio(headcount basis) in High income: OECD in 1994 to that in 1995?
Provide a succinct answer. 0.99. What is the ratio of the Pupil-teacher ratio(headcount basis) of Middle East & North Africa (all income levels) in 1994 to that in 1995?
Offer a very short reply. 1.02. What is the ratio of the Pupil-teacher ratio(headcount basis) of Malta in 1994 to that in 1995?
Your response must be concise. 1.02. What is the ratio of the Pupil-teacher ratio(headcount basis) of Swaziland in 1994 to that in 1995?
Offer a terse response. 0.96. What is the ratio of the Pupil-teacher ratio(headcount basis) in Middle East & North Africa (all income levels) in 1994 to that in 1996?
Offer a terse response. 1.01. What is the ratio of the Pupil-teacher ratio(headcount basis) in Malta in 1994 to that in 1996?
Your response must be concise. 1.03. What is the ratio of the Pupil-teacher ratio(headcount basis) of Swaziland in 1994 to that in 1996?
Keep it short and to the point. 0.97. What is the ratio of the Pupil-teacher ratio(headcount basis) of High income: OECD in 1994 to that in 1997?
Give a very brief answer. 1. What is the ratio of the Pupil-teacher ratio(headcount basis) in Middle East & North Africa (all income levels) in 1994 to that in 1997?
Your answer should be very brief. 1.04. What is the ratio of the Pupil-teacher ratio(headcount basis) of Malta in 1994 to that in 1997?
Give a very brief answer. 1.06. What is the ratio of the Pupil-teacher ratio(headcount basis) in Swaziland in 1994 to that in 1997?
Your response must be concise. 0.97. What is the ratio of the Pupil-teacher ratio(headcount basis) of High income: OECD in 1994 to that in 1998?
Your answer should be very brief. 0.99. What is the ratio of the Pupil-teacher ratio(headcount basis) of Middle East & North Africa (all income levels) in 1994 to that in 1998?
Give a very brief answer. 1.05. What is the ratio of the Pupil-teacher ratio(headcount basis) in Malta in 1994 to that in 1998?
Make the answer very short. 1.07. What is the ratio of the Pupil-teacher ratio(headcount basis) of Swaziland in 1994 to that in 1998?
Your answer should be compact. 0.97. What is the ratio of the Pupil-teacher ratio(headcount basis) of Middle East & North Africa (all income levels) in 1995 to that in 1996?
Make the answer very short. 0.99. What is the ratio of the Pupil-teacher ratio(headcount basis) of Malta in 1995 to that in 1996?
Give a very brief answer. 1.01. What is the ratio of the Pupil-teacher ratio(headcount basis) of High income: OECD in 1995 to that in 1997?
Provide a short and direct response. 1.01. What is the ratio of the Pupil-teacher ratio(headcount basis) in Middle East & North Africa (all income levels) in 1995 to that in 1997?
Your answer should be compact. 1.02. What is the ratio of the Pupil-teacher ratio(headcount basis) of Malta in 1995 to that in 1997?
Provide a succinct answer. 1.04. What is the ratio of the Pupil-teacher ratio(headcount basis) in Swaziland in 1995 to that in 1997?
Make the answer very short. 1.01. What is the ratio of the Pupil-teacher ratio(headcount basis) in High income: OECD in 1995 to that in 1998?
Offer a very short reply. 1. What is the ratio of the Pupil-teacher ratio(headcount basis) of Middle East & North Africa (all income levels) in 1995 to that in 1998?
Offer a terse response. 1.03. What is the ratio of the Pupil-teacher ratio(headcount basis) in Malta in 1995 to that in 1998?
Your response must be concise. 1.05. What is the ratio of the Pupil-teacher ratio(headcount basis) of Swaziland in 1995 to that in 1998?
Your response must be concise. 1.01. What is the ratio of the Pupil-teacher ratio(headcount basis) of High income: OECD in 1996 to that in 1997?
Give a very brief answer. 1.01. What is the ratio of the Pupil-teacher ratio(headcount basis) in Middle East & North Africa (all income levels) in 1996 to that in 1997?
Your answer should be very brief. 1.04. What is the ratio of the Pupil-teacher ratio(headcount basis) in Malta in 1996 to that in 1997?
Offer a terse response. 1.03. What is the ratio of the Pupil-teacher ratio(headcount basis) in High income: OECD in 1996 to that in 1998?
Your answer should be very brief. 1. What is the ratio of the Pupil-teacher ratio(headcount basis) of Middle East & North Africa (all income levels) in 1996 to that in 1998?
Offer a terse response. 1.04. What is the ratio of the Pupil-teacher ratio(headcount basis) of Malta in 1996 to that in 1998?
Your answer should be very brief. 1.05. What is the ratio of the Pupil-teacher ratio(headcount basis) of Middle East & North Africa (all income levels) in 1997 to that in 1998?
Make the answer very short. 1. What is the ratio of the Pupil-teacher ratio(headcount basis) of Malta in 1997 to that in 1998?
Your response must be concise. 1.01. What is the difference between the highest and the second highest Pupil-teacher ratio(headcount basis) of High income: OECD?
Keep it short and to the point. 0.1. What is the difference between the highest and the second highest Pupil-teacher ratio(headcount basis) in Middle East & North Africa (all income levels)?
Your answer should be compact. 0.04. What is the difference between the highest and the second highest Pupil-teacher ratio(headcount basis) in Malta?
Your answer should be compact. 0.69. What is the difference between the highest and the second highest Pupil-teacher ratio(headcount basis) of Swaziland?
Your answer should be very brief. 0.14. What is the difference between the highest and the lowest Pupil-teacher ratio(headcount basis) of High income: OECD?
Your response must be concise. 0.48. What is the difference between the highest and the lowest Pupil-teacher ratio(headcount basis) in Middle East & North Africa (all income levels)?
Offer a terse response. 1.14. What is the difference between the highest and the lowest Pupil-teacher ratio(headcount basis) of Malta?
Offer a terse response. 2.68. What is the difference between the highest and the lowest Pupil-teacher ratio(headcount basis) of Swaziland?
Offer a terse response. 1.32. 